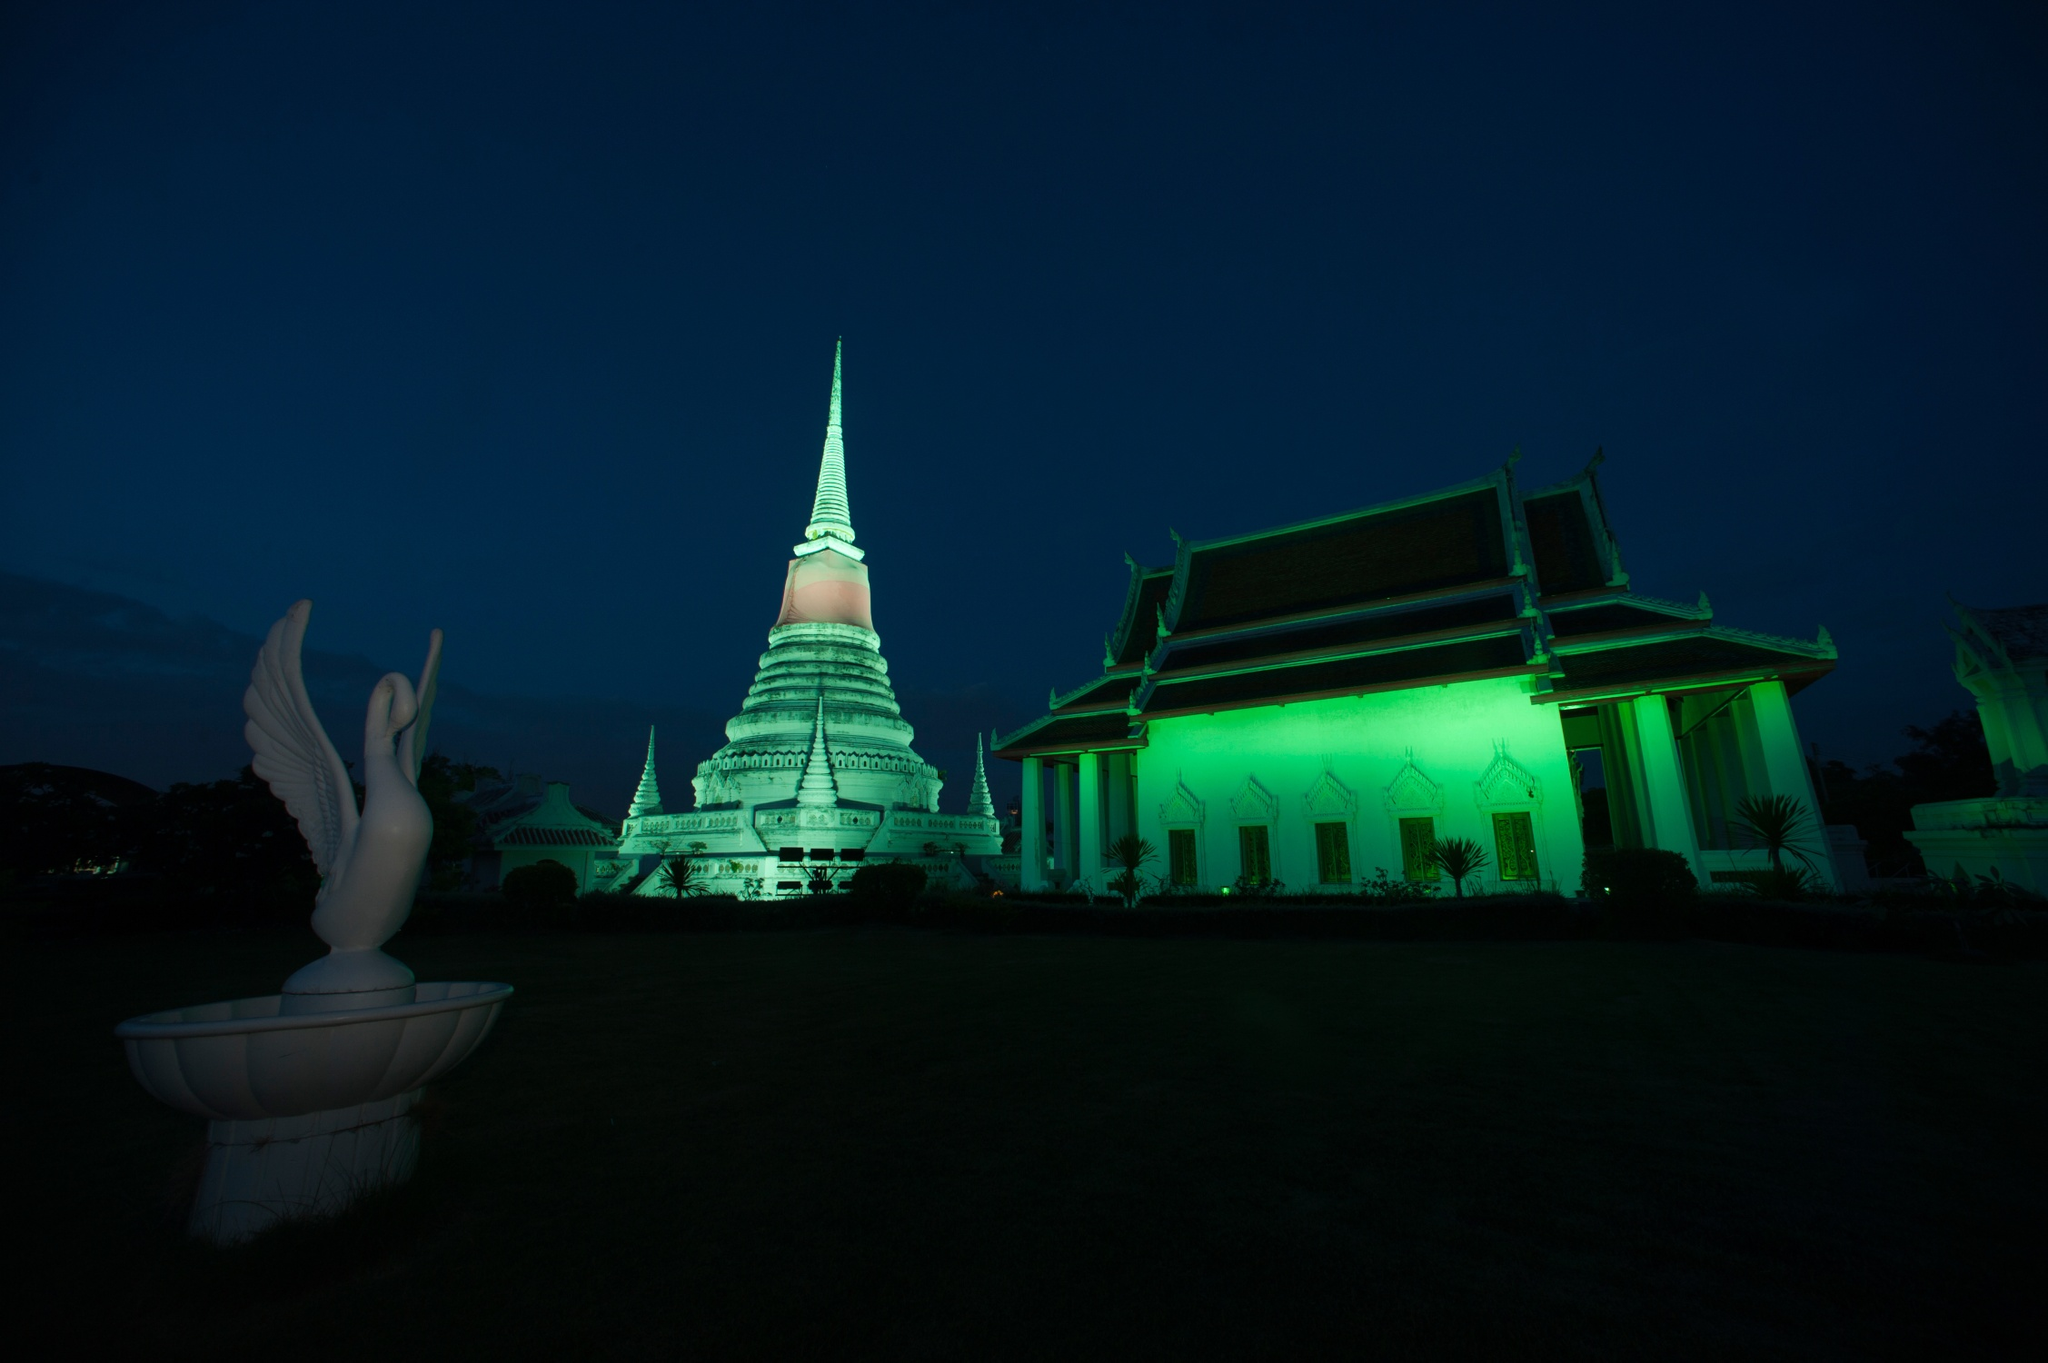What do you see happening in this image? The image depicts the Wat Phra Mahathat Woramahawihan temple in Nakhon Si Thammarat, Thailand. Illuminated by striking green lights against a deep blue evening sky, the temple's tall white spire, adorned with gold trimmings and a red roof, stands prominently. In front of the temple is a white statue of a bird with its wings spread open, adding elegance and a mystical ambiance. The photograph, taken from a low angle, offers a grandiose perspective of the temple's intricate architecture and peaceful surroundings. 